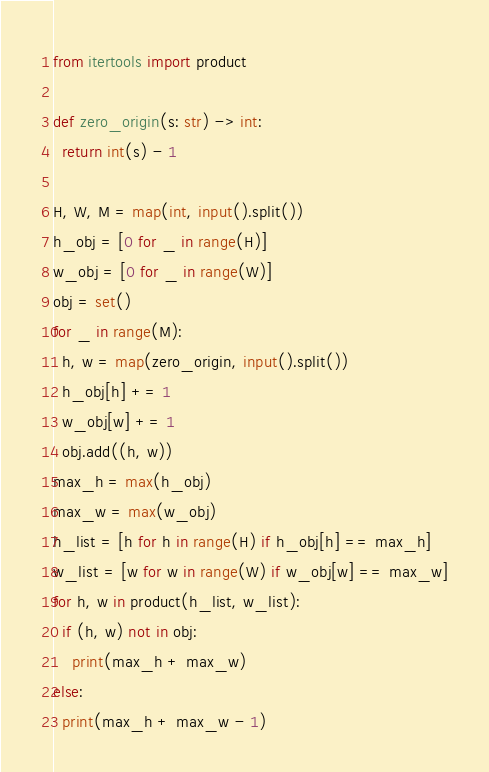<code> <loc_0><loc_0><loc_500><loc_500><_Python_>from itertools import product

def zero_origin(s: str) -> int:
  return int(s) - 1

H, W, M = map(int, input().split())
h_obj = [0 for _ in range(H)]
w_obj = [0 for _ in range(W)]
obj = set()
for _ in range(M):
  h, w = map(zero_origin, input().split())
  h_obj[h] += 1
  w_obj[w] += 1
  obj.add((h, w))
max_h = max(h_obj)
max_w = max(w_obj)
h_list = [h for h in range(H) if h_obj[h] == max_h]
w_list = [w for w in range(W) if w_obj[w] == max_w]
for h, w in product(h_list, w_list):
  if (h, w) not in obj:
    print(max_h + max_w)
else:
  print(max_h + max_w - 1)</code> 